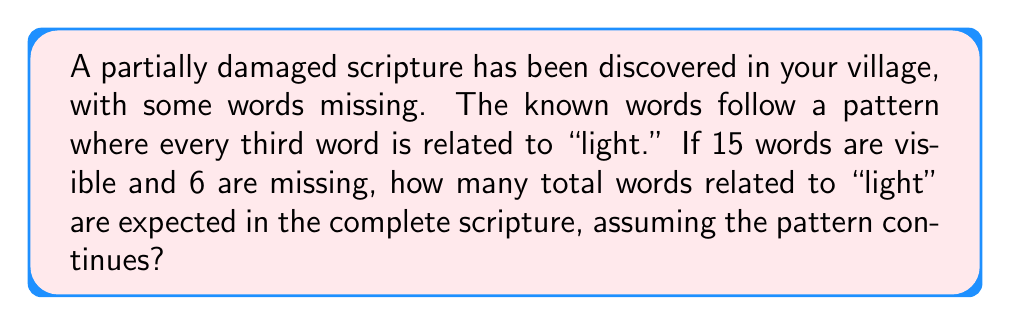Can you solve this math problem? Let's approach this step-by-step:

1. Understand the pattern:
   Every third word is related to "light"

2. Count the visible words:
   There are 15 visible words

3. Count the missing words:
   There are 6 missing words

4. Calculate the total words:
   Total words = Visible words + Missing words
   $$ 15 + 6 = 21 $$

5. Determine how many complete sets of 3 words are in the scripture:
   Number of complete sets = Total words ÷ 3
   $$ 21 \div 3 = 7 $$

6. Calculate the number of "light" related words:
   Each set of 3 words contains 1 "light" related word
   Number of "light" words = Number of complete sets
   $$ 7 $$

Therefore, we expect 7 words related to "light" in the complete scripture.
Answer: 7 